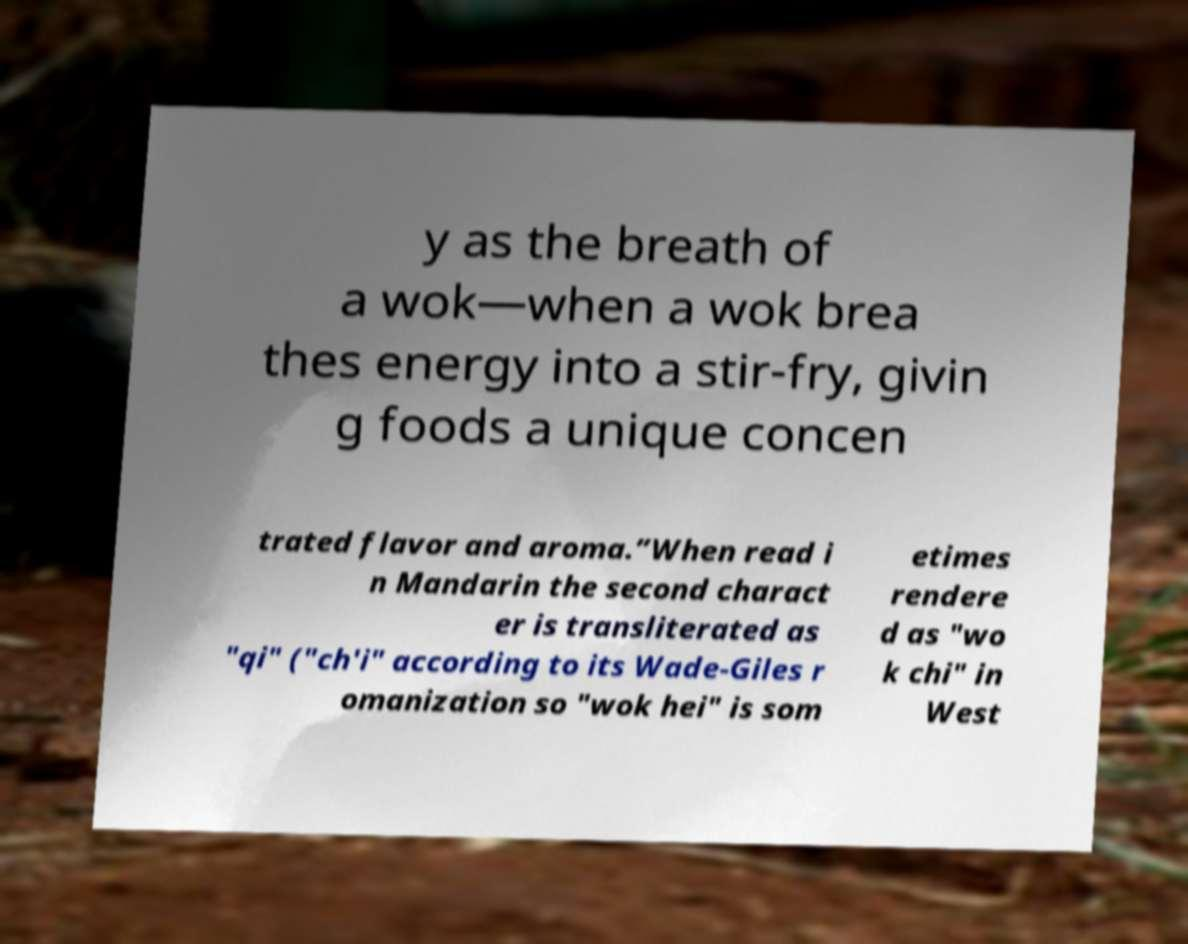There's text embedded in this image that I need extracted. Can you transcribe it verbatim? y as the breath of a wok—when a wok brea thes energy into a stir-fry, givin g foods a unique concen trated flavor and aroma.”When read i n Mandarin the second charact er is transliterated as "qi" ("ch'i" according to its Wade-Giles r omanization so "wok hei" is som etimes rendere d as "wo k chi" in West 